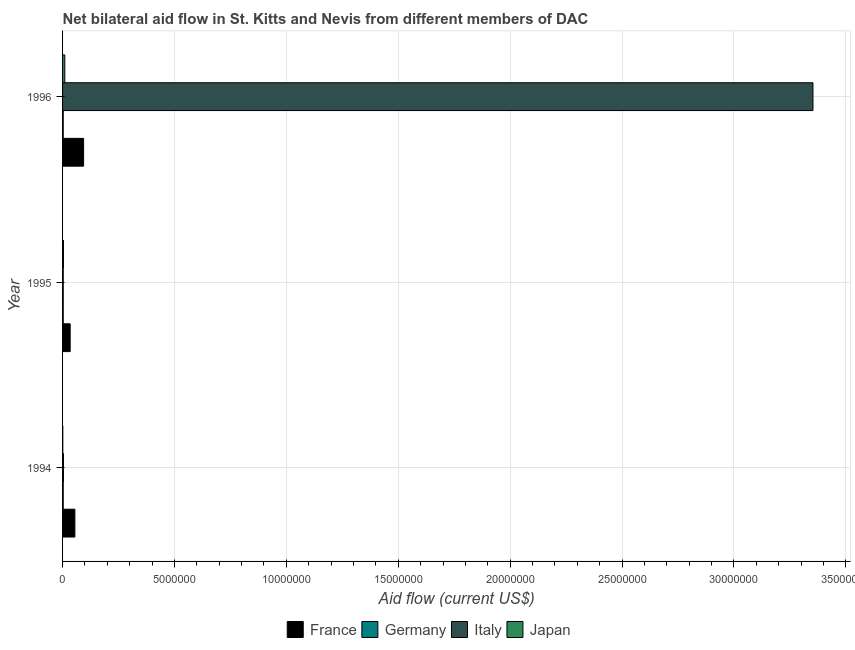How many different coloured bars are there?
Give a very brief answer. 4. Are the number of bars per tick equal to the number of legend labels?
Ensure brevity in your answer.  Yes. What is the amount of aid given by japan in 1994?
Your answer should be very brief. 10000. Across all years, what is the maximum amount of aid given by japan?
Provide a succinct answer. 1.00e+05. Across all years, what is the minimum amount of aid given by japan?
Offer a terse response. 10000. In which year was the amount of aid given by germany maximum?
Give a very brief answer. 1994. In which year was the amount of aid given by france minimum?
Your answer should be compact. 1995. What is the total amount of aid given by france in the graph?
Offer a terse response. 1.83e+06. What is the difference between the amount of aid given by france in 1994 and that in 1996?
Give a very brief answer. -3.90e+05. What is the difference between the amount of aid given by germany in 1995 and the amount of aid given by japan in 1996?
Your response must be concise. -7.00e+04. What is the average amount of aid given by germany per year?
Keep it short and to the point. 3.00e+04. In the year 1994, what is the difference between the amount of aid given by japan and amount of aid given by germany?
Offer a terse response. -2.00e+04. In how many years, is the amount of aid given by france greater than 34000000 US$?
Keep it short and to the point. 0. Is the amount of aid given by germany in 1994 less than that in 1996?
Ensure brevity in your answer.  No. Is the difference between the amount of aid given by italy in 1994 and 1995 greater than the difference between the amount of aid given by france in 1994 and 1995?
Your response must be concise. No. What is the difference between the highest and the second highest amount of aid given by france?
Your answer should be very brief. 3.90e+05. What is the difference between the highest and the lowest amount of aid given by italy?
Offer a terse response. 3.35e+07. Is the sum of the amount of aid given by germany in 1994 and 1996 greater than the maximum amount of aid given by france across all years?
Ensure brevity in your answer.  No. What does the 3rd bar from the bottom in 1996 represents?
Your answer should be very brief. Italy. Is it the case that in every year, the sum of the amount of aid given by france and amount of aid given by germany is greater than the amount of aid given by italy?
Offer a terse response. No. Does the graph contain any zero values?
Make the answer very short. No. Where does the legend appear in the graph?
Offer a terse response. Bottom center. How are the legend labels stacked?
Keep it short and to the point. Horizontal. What is the title of the graph?
Make the answer very short. Net bilateral aid flow in St. Kitts and Nevis from different members of DAC. Does "SF6 gas" appear as one of the legend labels in the graph?
Give a very brief answer. No. What is the Aid flow (current US$) of France in 1994?
Keep it short and to the point. 5.50e+05. What is the Aid flow (current US$) of Germany in 1994?
Give a very brief answer. 3.00e+04. What is the Aid flow (current US$) of Italy in 1994?
Offer a very short reply. 4.00e+04. What is the Aid flow (current US$) of France in 1995?
Your answer should be very brief. 3.40e+05. What is the Aid flow (current US$) in Italy in 1995?
Keep it short and to the point. 3.00e+04. What is the Aid flow (current US$) of France in 1996?
Give a very brief answer. 9.40e+05. What is the Aid flow (current US$) in Germany in 1996?
Offer a terse response. 3.00e+04. What is the Aid flow (current US$) in Italy in 1996?
Offer a terse response. 3.35e+07. What is the Aid flow (current US$) of Japan in 1996?
Your answer should be compact. 1.00e+05. Across all years, what is the maximum Aid flow (current US$) in France?
Give a very brief answer. 9.40e+05. Across all years, what is the maximum Aid flow (current US$) of Germany?
Your response must be concise. 3.00e+04. Across all years, what is the maximum Aid flow (current US$) of Italy?
Your answer should be compact. 3.35e+07. Across all years, what is the minimum Aid flow (current US$) of Germany?
Provide a short and direct response. 3.00e+04. Across all years, what is the minimum Aid flow (current US$) of Italy?
Offer a terse response. 3.00e+04. Across all years, what is the minimum Aid flow (current US$) in Japan?
Ensure brevity in your answer.  10000. What is the total Aid flow (current US$) in France in the graph?
Offer a terse response. 1.83e+06. What is the total Aid flow (current US$) of Germany in the graph?
Offer a very short reply. 9.00e+04. What is the total Aid flow (current US$) of Italy in the graph?
Your response must be concise. 3.36e+07. What is the total Aid flow (current US$) in Japan in the graph?
Ensure brevity in your answer.  1.50e+05. What is the difference between the Aid flow (current US$) in France in 1994 and that in 1995?
Offer a terse response. 2.10e+05. What is the difference between the Aid flow (current US$) of Germany in 1994 and that in 1995?
Provide a succinct answer. 0. What is the difference between the Aid flow (current US$) in Italy in 1994 and that in 1995?
Make the answer very short. 10000. What is the difference between the Aid flow (current US$) in France in 1994 and that in 1996?
Your response must be concise. -3.90e+05. What is the difference between the Aid flow (current US$) in Italy in 1994 and that in 1996?
Your answer should be very brief. -3.35e+07. What is the difference between the Aid flow (current US$) in Japan in 1994 and that in 1996?
Your answer should be compact. -9.00e+04. What is the difference between the Aid flow (current US$) of France in 1995 and that in 1996?
Provide a succinct answer. -6.00e+05. What is the difference between the Aid flow (current US$) in Germany in 1995 and that in 1996?
Ensure brevity in your answer.  0. What is the difference between the Aid flow (current US$) of Italy in 1995 and that in 1996?
Your response must be concise. -3.35e+07. What is the difference between the Aid flow (current US$) in Japan in 1995 and that in 1996?
Provide a succinct answer. -6.00e+04. What is the difference between the Aid flow (current US$) of France in 1994 and the Aid flow (current US$) of Germany in 1995?
Your answer should be compact. 5.20e+05. What is the difference between the Aid flow (current US$) of France in 1994 and the Aid flow (current US$) of Italy in 1995?
Give a very brief answer. 5.20e+05. What is the difference between the Aid flow (current US$) in France in 1994 and the Aid flow (current US$) in Japan in 1995?
Make the answer very short. 5.10e+05. What is the difference between the Aid flow (current US$) of Germany in 1994 and the Aid flow (current US$) of Japan in 1995?
Provide a short and direct response. -10000. What is the difference between the Aid flow (current US$) of France in 1994 and the Aid flow (current US$) of Germany in 1996?
Your response must be concise. 5.20e+05. What is the difference between the Aid flow (current US$) in France in 1994 and the Aid flow (current US$) in Italy in 1996?
Your answer should be compact. -3.30e+07. What is the difference between the Aid flow (current US$) in France in 1994 and the Aid flow (current US$) in Japan in 1996?
Ensure brevity in your answer.  4.50e+05. What is the difference between the Aid flow (current US$) of Germany in 1994 and the Aid flow (current US$) of Italy in 1996?
Make the answer very short. -3.35e+07. What is the difference between the Aid flow (current US$) of Italy in 1994 and the Aid flow (current US$) of Japan in 1996?
Keep it short and to the point. -6.00e+04. What is the difference between the Aid flow (current US$) in France in 1995 and the Aid flow (current US$) in Italy in 1996?
Provide a short and direct response. -3.32e+07. What is the difference between the Aid flow (current US$) in France in 1995 and the Aid flow (current US$) in Japan in 1996?
Your response must be concise. 2.40e+05. What is the difference between the Aid flow (current US$) in Germany in 1995 and the Aid flow (current US$) in Italy in 1996?
Keep it short and to the point. -3.35e+07. What is the difference between the Aid flow (current US$) in Germany in 1995 and the Aid flow (current US$) in Japan in 1996?
Your answer should be very brief. -7.00e+04. What is the difference between the Aid flow (current US$) of Italy in 1995 and the Aid flow (current US$) of Japan in 1996?
Your response must be concise. -7.00e+04. What is the average Aid flow (current US$) of Germany per year?
Make the answer very short. 3.00e+04. What is the average Aid flow (current US$) in Italy per year?
Your answer should be very brief. 1.12e+07. What is the average Aid flow (current US$) in Japan per year?
Offer a terse response. 5.00e+04. In the year 1994, what is the difference between the Aid flow (current US$) in France and Aid flow (current US$) in Germany?
Provide a short and direct response. 5.20e+05. In the year 1994, what is the difference between the Aid flow (current US$) in France and Aid flow (current US$) in Italy?
Provide a succinct answer. 5.10e+05. In the year 1994, what is the difference between the Aid flow (current US$) of France and Aid flow (current US$) of Japan?
Keep it short and to the point. 5.40e+05. In the year 1994, what is the difference between the Aid flow (current US$) of Germany and Aid flow (current US$) of Italy?
Ensure brevity in your answer.  -10000. In the year 1994, what is the difference between the Aid flow (current US$) of Germany and Aid flow (current US$) of Japan?
Offer a terse response. 2.00e+04. In the year 1995, what is the difference between the Aid flow (current US$) of France and Aid flow (current US$) of Germany?
Your response must be concise. 3.10e+05. In the year 1996, what is the difference between the Aid flow (current US$) of France and Aid flow (current US$) of Germany?
Your answer should be compact. 9.10e+05. In the year 1996, what is the difference between the Aid flow (current US$) in France and Aid flow (current US$) in Italy?
Provide a succinct answer. -3.26e+07. In the year 1996, what is the difference between the Aid flow (current US$) in France and Aid flow (current US$) in Japan?
Your answer should be very brief. 8.40e+05. In the year 1996, what is the difference between the Aid flow (current US$) in Germany and Aid flow (current US$) in Italy?
Give a very brief answer. -3.35e+07. In the year 1996, what is the difference between the Aid flow (current US$) of Germany and Aid flow (current US$) of Japan?
Ensure brevity in your answer.  -7.00e+04. In the year 1996, what is the difference between the Aid flow (current US$) in Italy and Aid flow (current US$) in Japan?
Keep it short and to the point. 3.34e+07. What is the ratio of the Aid flow (current US$) of France in 1994 to that in 1995?
Ensure brevity in your answer.  1.62. What is the ratio of the Aid flow (current US$) in Italy in 1994 to that in 1995?
Offer a very short reply. 1.33. What is the ratio of the Aid flow (current US$) of Japan in 1994 to that in 1995?
Provide a succinct answer. 0.25. What is the ratio of the Aid flow (current US$) of France in 1994 to that in 1996?
Your answer should be very brief. 0.59. What is the ratio of the Aid flow (current US$) in Italy in 1994 to that in 1996?
Keep it short and to the point. 0. What is the ratio of the Aid flow (current US$) of France in 1995 to that in 1996?
Offer a terse response. 0.36. What is the ratio of the Aid flow (current US$) of Germany in 1995 to that in 1996?
Make the answer very short. 1. What is the ratio of the Aid flow (current US$) of Italy in 1995 to that in 1996?
Your answer should be compact. 0. What is the ratio of the Aid flow (current US$) in Japan in 1995 to that in 1996?
Your answer should be very brief. 0.4. What is the difference between the highest and the second highest Aid flow (current US$) of France?
Your answer should be compact. 3.90e+05. What is the difference between the highest and the second highest Aid flow (current US$) of Germany?
Provide a succinct answer. 0. What is the difference between the highest and the second highest Aid flow (current US$) of Italy?
Give a very brief answer. 3.35e+07. What is the difference between the highest and the second highest Aid flow (current US$) of Japan?
Provide a succinct answer. 6.00e+04. What is the difference between the highest and the lowest Aid flow (current US$) in Italy?
Keep it short and to the point. 3.35e+07. 